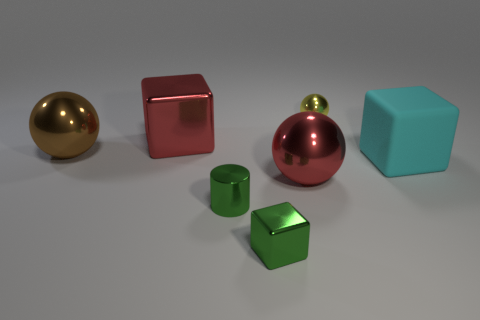Subtract all big brown shiny balls. How many balls are left? 2 Add 2 green matte spheres. How many objects exist? 9 Subtract all green blocks. How many blocks are left? 2 Subtract all spheres. How many objects are left? 4 Subtract all green cylinders. How many cyan balls are left? 0 Subtract 1 green cylinders. How many objects are left? 6 Subtract 3 blocks. How many blocks are left? 0 Subtract all red spheres. Subtract all yellow cylinders. How many spheres are left? 2 Subtract all brown things. Subtract all green metal cubes. How many objects are left? 5 Add 6 large rubber cubes. How many large rubber cubes are left? 7 